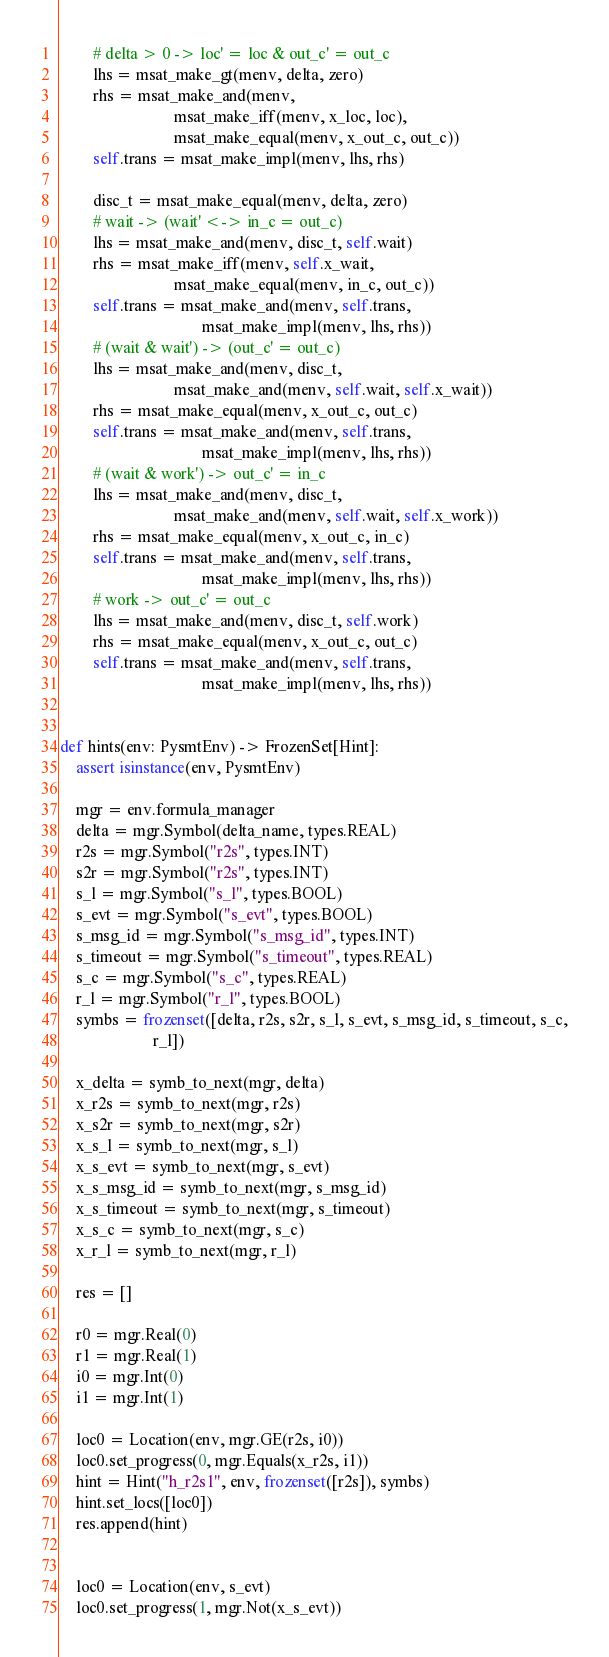<code> <loc_0><loc_0><loc_500><loc_500><_Python_>        # delta > 0 -> loc' = loc & out_c' = out_c
        lhs = msat_make_gt(menv, delta, zero)
        rhs = msat_make_and(menv,
                            msat_make_iff(menv, x_loc, loc),
                            msat_make_equal(menv, x_out_c, out_c))
        self.trans = msat_make_impl(menv, lhs, rhs)

        disc_t = msat_make_equal(menv, delta, zero)
        # wait -> (wait' <-> in_c = out_c)
        lhs = msat_make_and(menv, disc_t, self.wait)
        rhs = msat_make_iff(menv, self.x_wait,
                            msat_make_equal(menv, in_c, out_c))
        self.trans = msat_make_and(menv, self.trans,
                                   msat_make_impl(menv, lhs, rhs))
        # (wait & wait') -> (out_c' = out_c)
        lhs = msat_make_and(menv, disc_t,
                            msat_make_and(menv, self.wait, self.x_wait))
        rhs = msat_make_equal(menv, x_out_c, out_c)
        self.trans = msat_make_and(menv, self.trans,
                                   msat_make_impl(menv, lhs, rhs))
        # (wait & work') -> out_c' = in_c
        lhs = msat_make_and(menv, disc_t,
                            msat_make_and(menv, self.wait, self.x_work))
        rhs = msat_make_equal(menv, x_out_c, in_c)
        self.trans = msat_make_and(menv, self.trans,
                                   msat_make_impl(menv, lhs, rhs))
        # work -> out_c' = out_c
        lhs = msat_make_and(menv, disc_t, self.work)
        rhs = msat_make_equal(menv, x_out_c, out_c)
        self.trans = msat_make_and(menv, self.trans,
                                   msat_make_impl(menv, lhs, rhs))


def hints(env: PysmtEnv) -> FrozenSet[Hint]:
    assert isinstance(env, PysmtEnv)

    mgr = env.formula_manager
    delta = mgr.Symbol(delta_name, types.REAL)
    r2s = mgr.Symbol("r2s", types.INT)
    s2r = mgr.Symbol("r2s", types.INT)
    s_l = mgr.Symbol("s_l", types.BOOL)
    s_evt = mgr.Symbol("s_evt", types.BOOL)
    s_msg_id = mgr.Symbol("s_msg_id", types.INT)
    s_timeout = mgr.Symbol("s_timeout", types.REAL)
    s_c = mgr.Symbol("s_c", types.REAL)
    r_l = mgr.Symbol("r_l", types.BOOL)
    symbs = frozenset([delta, r2s, s2r, s_l, s_evt, s_msg_id, s_timeout, s_c,
                       r_l])

    x_delta = symb_to_next(mgr, delta)
    x_r2s = symb_to_next(mgr, r2s)
    x_s2r = symb_to_next(mgr, s2r)
    x_s_l = symb_to_next(mgr, s_l)
    x_s_evt = symb_to_next(mgr, s_evt)
    x_s_msg_id = symb_to_next(mgr, s_msg_id)
    x_s_timeout = symb_to_next(mgr, s_timeout)
    x_s_c = symb_to_next(mgr, s_c)
    x_r_l = symb_to_next(mgr, r_l)

    res = []

    r0 = mgr.Real(0)
    r1 = mgr.Real(1)
    i0 = mgr.Int(0)
    i1 = mgr.Int(1)

    loc0 = Location(env, mgr.GE(r2s, i0))
    loc0.set_progress(0, mgr.Equals(x_r2s, i1))
    hint = Hint("h_r2s1", env, frozenset([r2s]), symbs)
    hint.set_locs([loc0])
    res.append(hint)


    loc0 = Location(env, s_evt)
    loc0.set_progress(1, mgr.Not(x_s_evt))</code> 